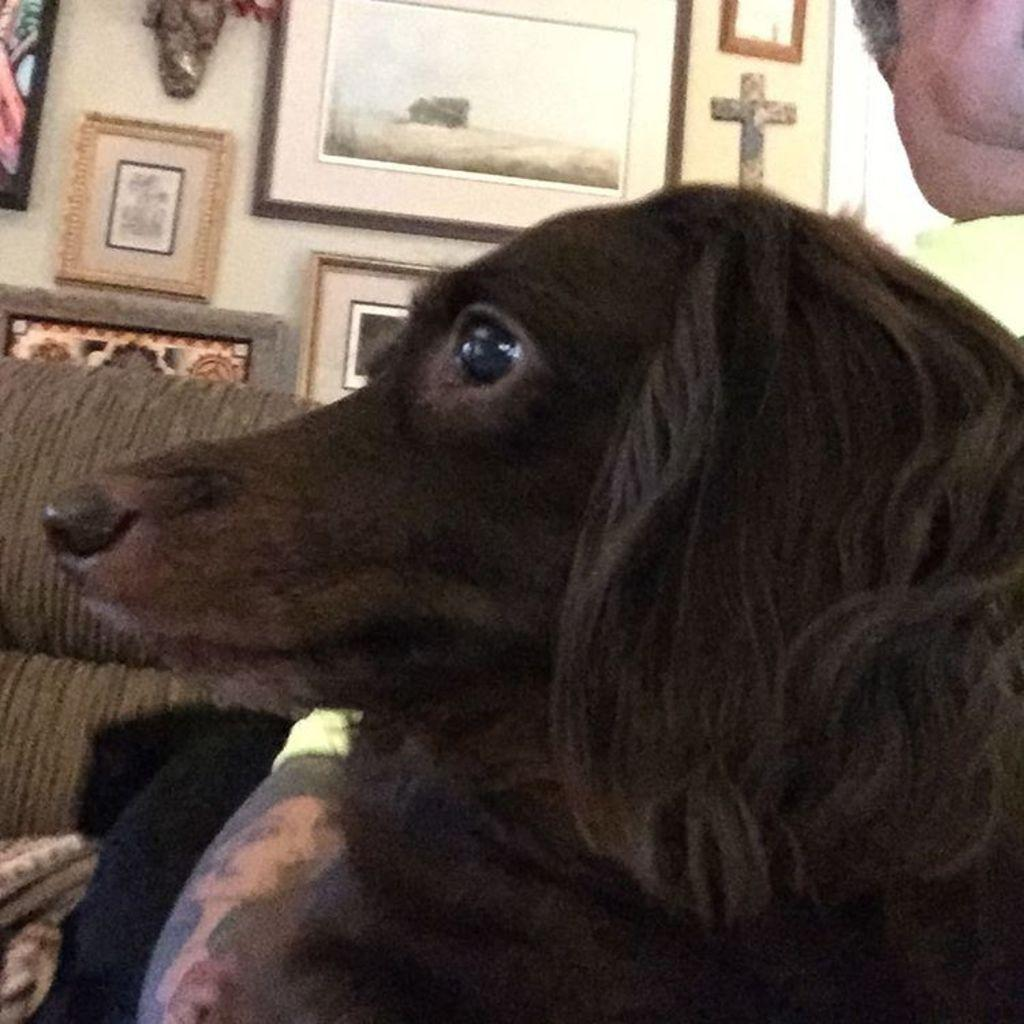What type of animal is in the image? There is a dog in the image. What color is the dog? The dog is black in color. What piece of furniture is to the left of the dog? There is a couch to the left of the dog. What can be seen on the wall in the background? There are many frames on the wall in the background. What type of rice is being served at the feast in the image? There is no feast or rice present in the image; it features a dog, a couch, and frames on the wall. 